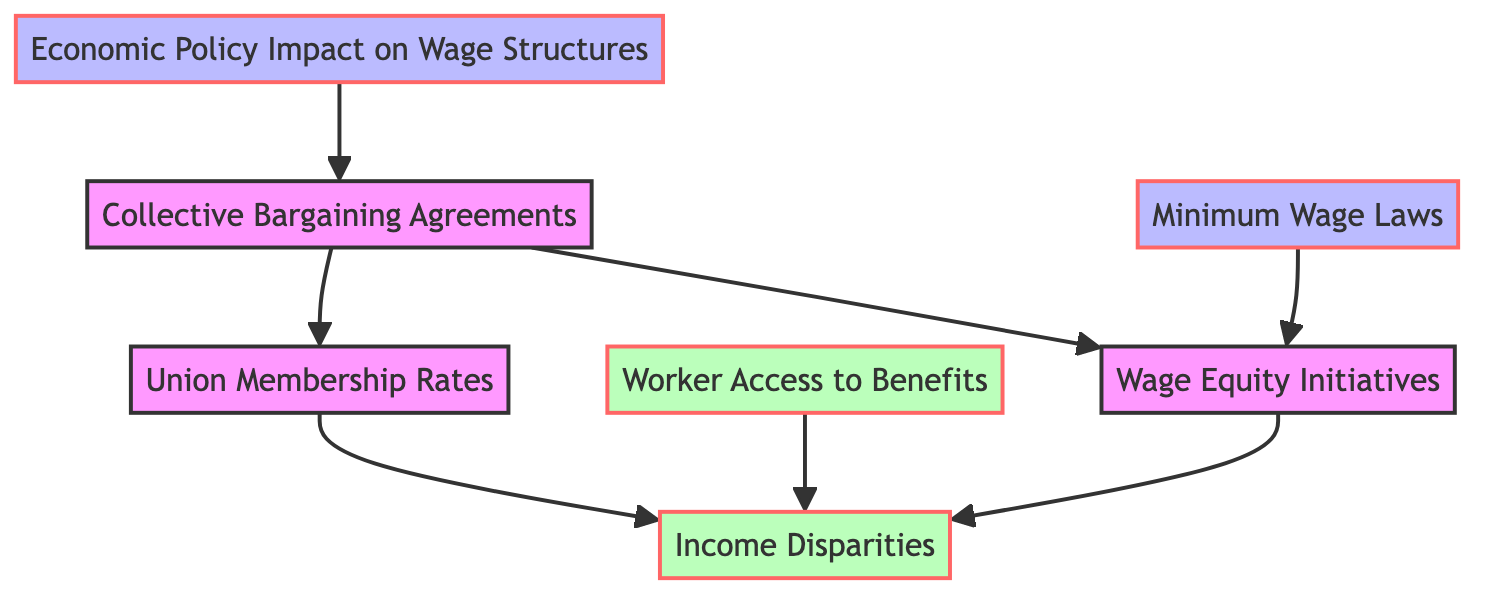What is the total number of nodes in the diagram? The diagram contains several distinct entities represented as nodes. Counting all the unique nodes listed gives us a total of 7 nodes.
Answer: 7 How many edges connect "Collective Bargaining Agreements" to other nodes? "Collective Bargaining Agreements" has outgoing edges to "Wage Equity" and "Union Membership", indicating two connections to other nodes.
Answer: 2 What is the relationship between "Wage Equity Initiatives" and "Income Disparities"? "Wage Equity Initiatives" has a direct connection to "Income Disparities" through a directed edge, indicating that wage equity initiatives influence income disparities.
Answer: influence What are the two nodes that lead to "Income Disparities"? The nodes that connect to "Income Disparities" are "Wage Equity Initiatives" and "Union Membership", both showing a direct influence on income disparities.
Answer: Wage Equity Initiatives, Union Membership Which node influences "Collective Bargaining Agreements"? "Economic Policy Impact on Wage Structures" has a directed edge leading to "Collective Bargaining Agreements", indicating that economic policy impacts collective bargaining outcomes.
Answer: Economic Policy Impact on Wage Structures Which node is connected to both "Worker Access to Benefits" and "Income Disparities"? "Worker Access to Benefits" directly connects to "Income Disparities", showing that access to benefits has a relationship with income disparities as an outcome.
Answer: Worker Access to Benefits What type of initiatives does "Minimum Wage Laws" connect to? "Minimum Wage Laws" has a direct connection to "Wage Equity Initiatives", indicating that minimum wage laws aim to establish wage equity within the workforce.
Answer: Wage Equity Initiatives What outcome is affected by both "Union Membership Rates" and "Wage Equity Initiatives"? Both "Union Membership Rates" and "Wage Equity Initiatives" directly influence "Income Disparities", meaning that both factors affect the level of income disparities among workers.
Answer: Income Disparities How does "Collective Bargaining Agreements" relate to "Union Membership Rates"? There is a direct connection from "Collective Bargaining Agreements" to "Union Membership Rates", suggesting that these agreements are influenced by the levels of union membership.
Answer: influence 